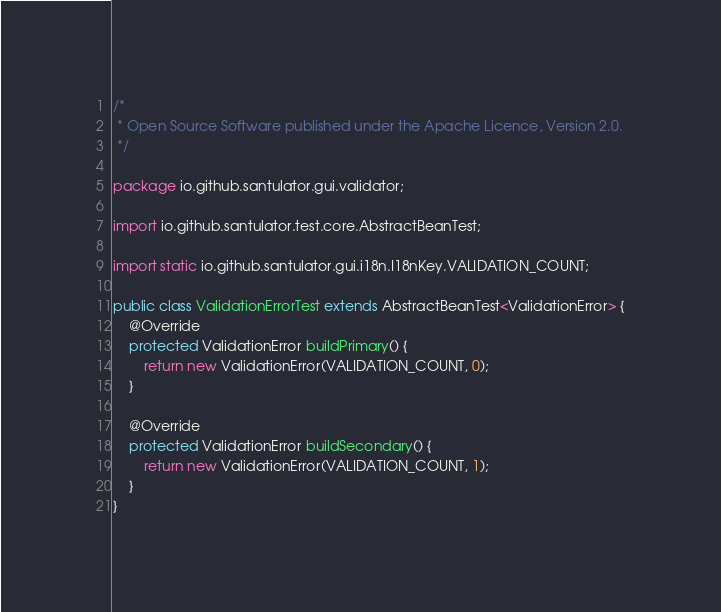<code> <loc_0><loc_0><loc_500><loc_500><_Java_>/*
 * Open Source Software published under the Apache Licence, Version 2.0.
 */

package io.github.santulator.gui.validator;

import io.github.santulator.test.core.AbstractBeanTest;

import static io.github.santulator.gui.i18n.I18nKey.VALIDATION_COUNT;

public class ValidationErrorTest extends AbstractBeanTest<ValidationError> {
    @Override
    protected ValidationError buildPrimary() {
        return new ValidationError(VALIDATION_COUNT, 0);
    }

    @Override
    protected ValidationError buildSecondary() {
        return new ValidationError(VALIDATION_COUNT, 1);
    }
}</code> 